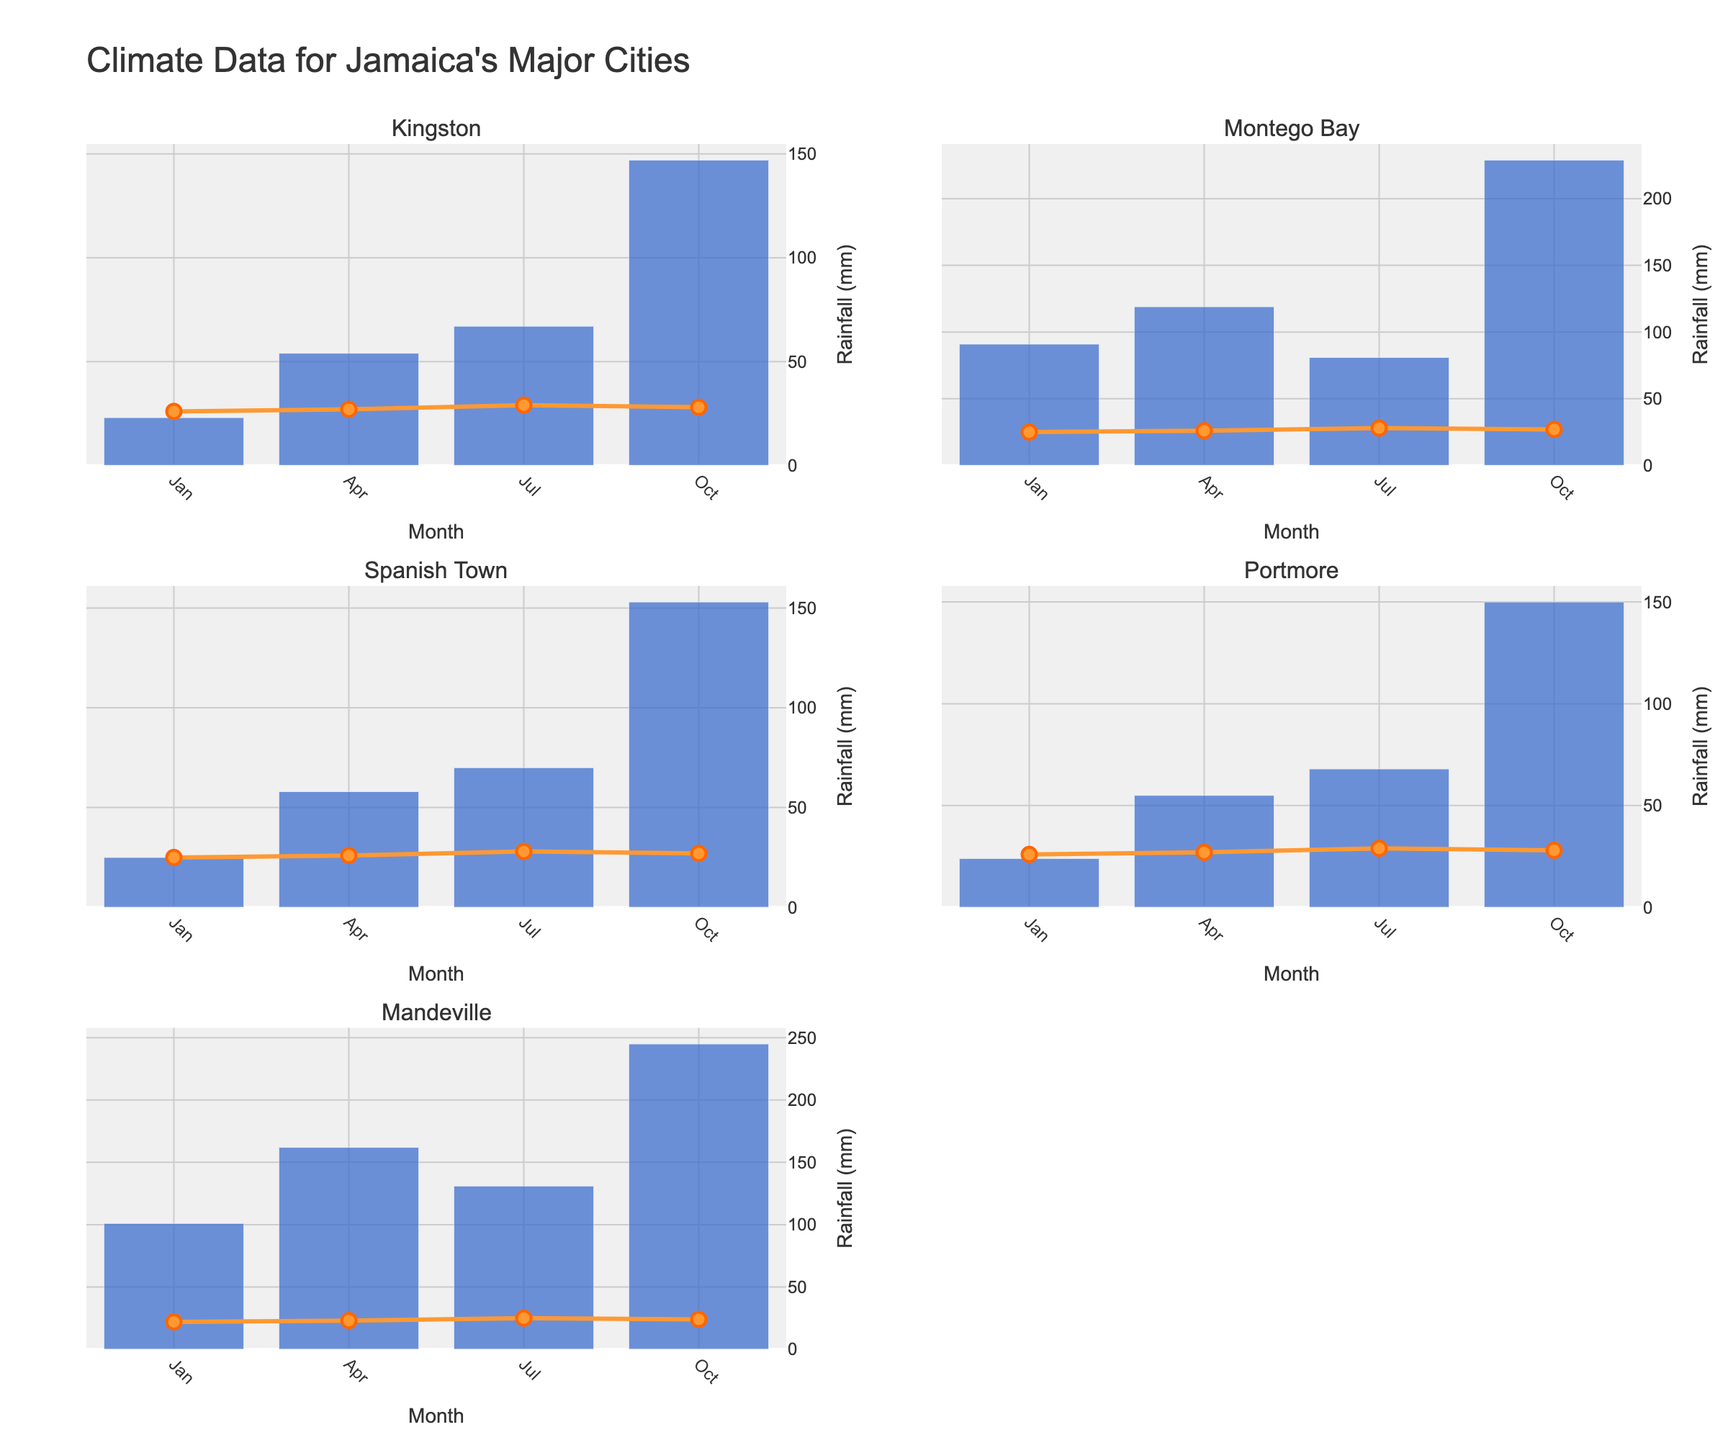what is the title of the figure? The title of the figure is prominently displayed at the top of the plot in large text.
Answer: Social Media Engagement for Anime-Inspired Digital Artwork Which artwork type received the highest number of Instagram likes? By examining the Instagram Likes subplot, find the bar with the highest value.
Answer: Fanart of Popular Anime How many artwork types received more than 1000 Twitter retweets? Look at the Twitter Retweets subplot and count the bars with values exceeding 1000.
Answer: 3 What is the combined number of DeviantArt Favorites for Mecha Designs and Cyberpunk Cityscapes? Add the values for Mecha Designs and Cyberpunk Cityscapes from the DeviantArt Favorites subplot.
Answer: 1050 Which platform shows the highest overall engagement for Chibi Art? Examine each subplot for Chibi Art and identify the highest value.
Answer: Twitter Retweets How much higher is the Tumblr Notes count for Fanart of Popular Anime compared to Cyberpunk Cityscapes? Subtract the Tumblr Notes value of Cyberpunk Cityscapes from that of Fanart of Popular Anime.
Answer: 600 Which artwork type has the most engaging content across all platforms? Find the artwork type with the highest values across the combined sum of all four subplots.
Answer: Fanart of Popular Anime What is the range of Instagram Likes received by all artwork types? Determine the difference between the maximum and minimum values in the Instagram Likes subplot.
Answer: 1050 Which two artwork types have the closest number of DeviantArt Favorites? Check the DeviantArt Favorites subplot and identify the two bars with the closest values.
Answer: Landscapes Backgrounds and Chibi Art For the Manga-style Comic Panels, what's the difference in engagement between Instagram Likes and DeviantArt Favorites? Subtract DeviantArt Favorites from Instagram Likes for Manga-style Comic Panels.
Answer: 400 